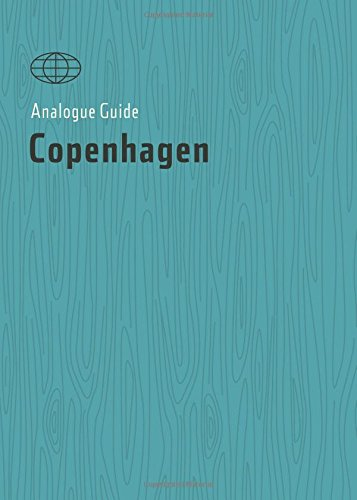What is the genre of this book? The genre of this book is Travel, specifically focused on Copenhagen, offering insightful and practical tips for visitors. 